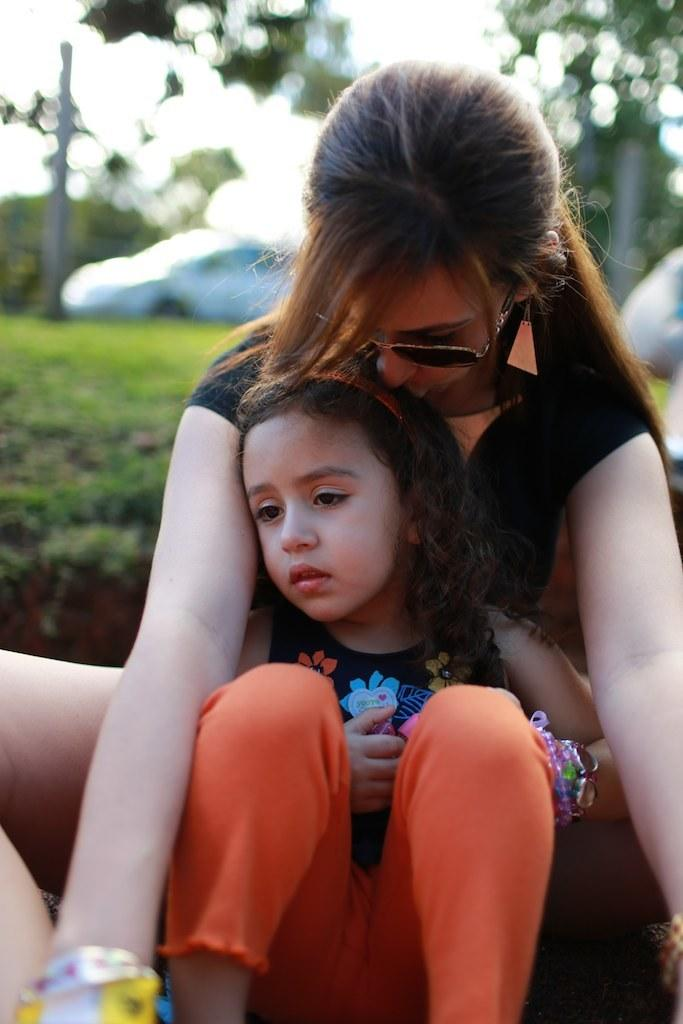Who is present in the image? There is a person and a kid in the image. What are the person and the kid wearing? Both the person and the kid are wearing clothes. Can you describe the background of the image? The background of the image is blurred. What type of wine is being served to the girl in the image? There is no girl or wine present in the image; it features a person and a kid. 